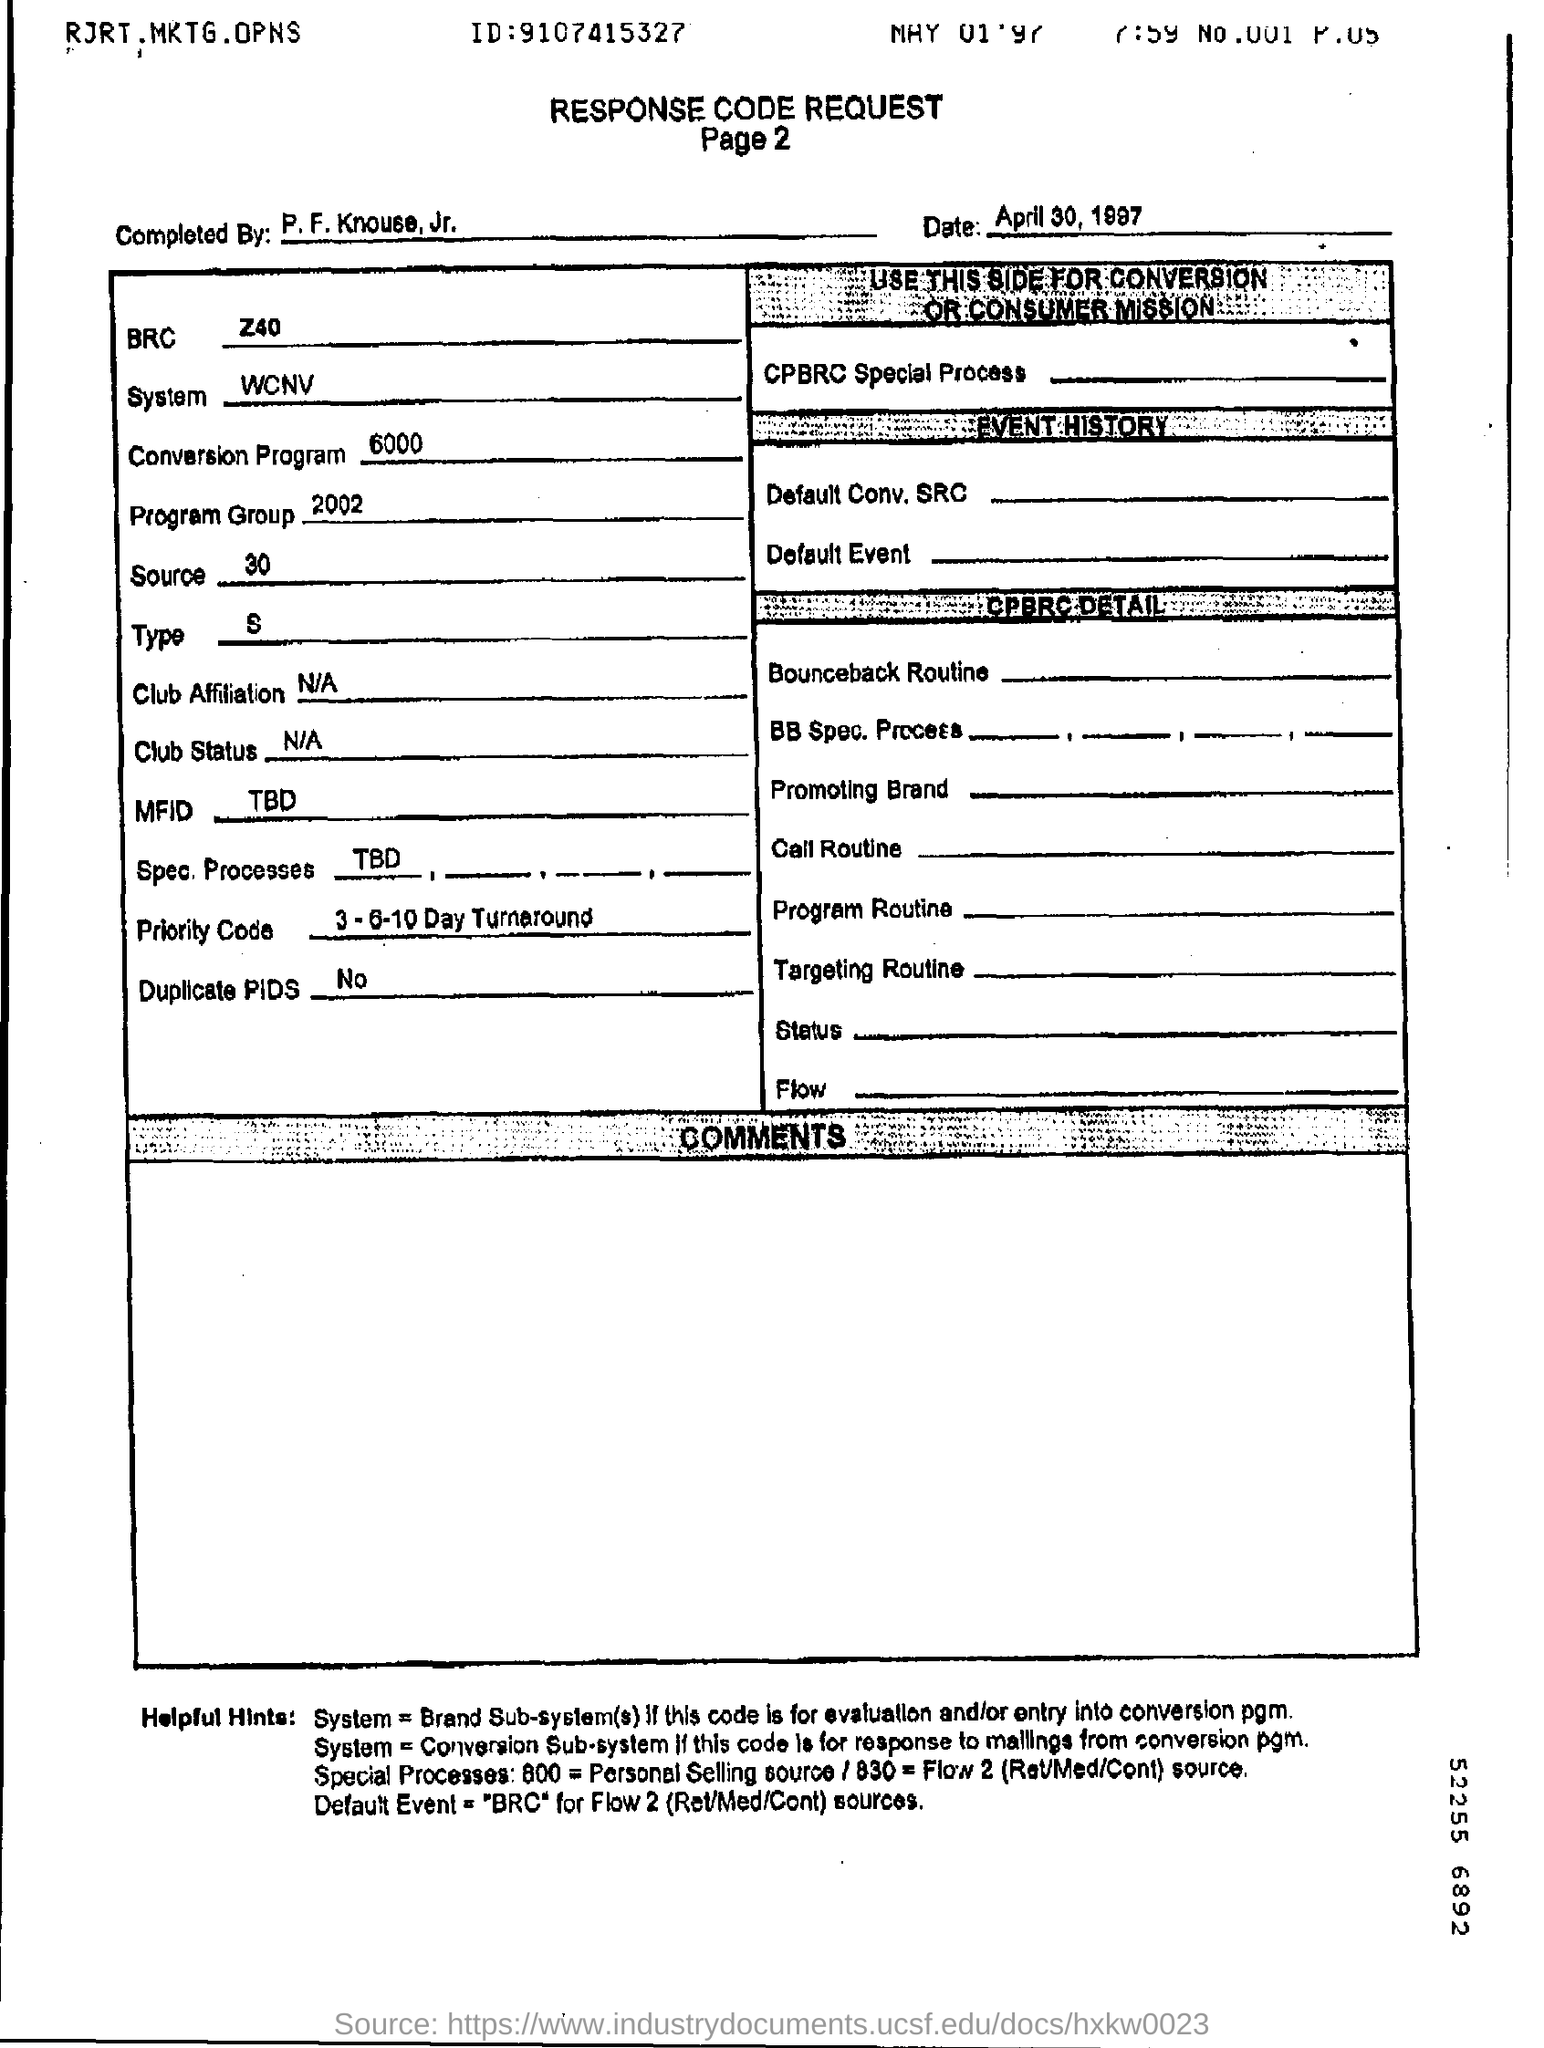Indicate a few pertinent items in this graphic. The heading of the document is 'Response Code Request'. 